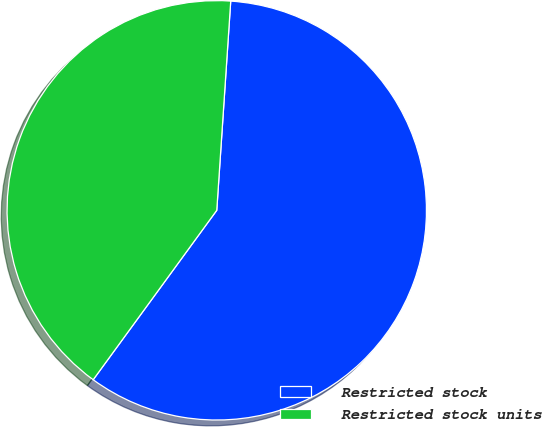Convert chart. <chart><loc_0><loc_0><loc_500><loc_500><pie_chart><fcel>Restricted stock<fcel>Restricted stock units<nl><fcel>58.97%<fcel>41.03%<nl></chart> 